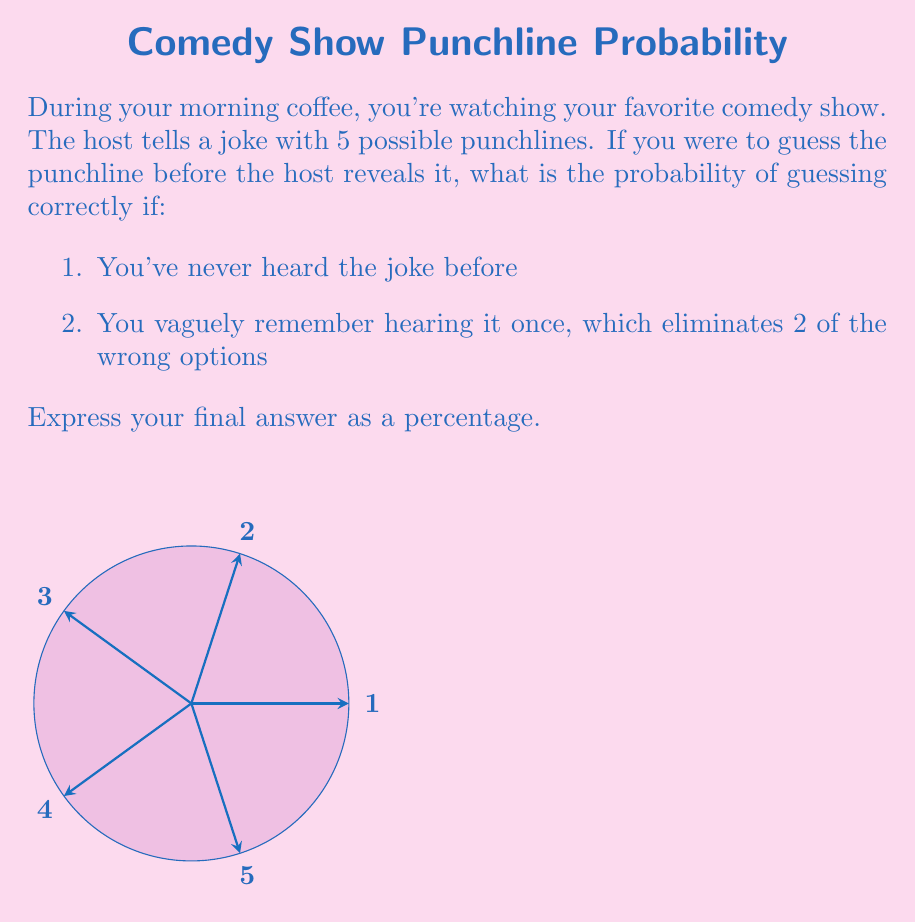Solve this math problem. Let's approach this step-by-step:

1. For the first scenario:
   - There are 5 possible punchlines.
   - You have no prior knowledge, so each punchline has an equal probability.
   - The probability of guessing correctly is:
     $$P(\text{correct guess}) = \frac{1}{\text{total options}} = \frac{1}{5} = 0.2$$

2. For the second scenario:
   - You vaguely remember the joke, eliminating 2 wrong options.
   - This leaves 3 options: 1 correct and 2 incorrect.
   - The probability of guessing correctly now is:
     $$P(\text{correct guess}) = \frac{1}{\text{remaining options}} = \frac{1}{3} \approx 0.3333$$

3. To express the final answer as a percentage:
   - For the first scenario: $0.2 \times 100\% = 20\%$
   - For the second scenario: $\frac{1}{3} \times 100\% \approx 33.33\%$

4. The difference in probability:
   $$33.33\% - 20\% = 13.33\%$$

This shows that vaguely remembering the joke increases your chances of guessing correctly by about 13.33 percentage points.
Answer: 20% and 33.33% 